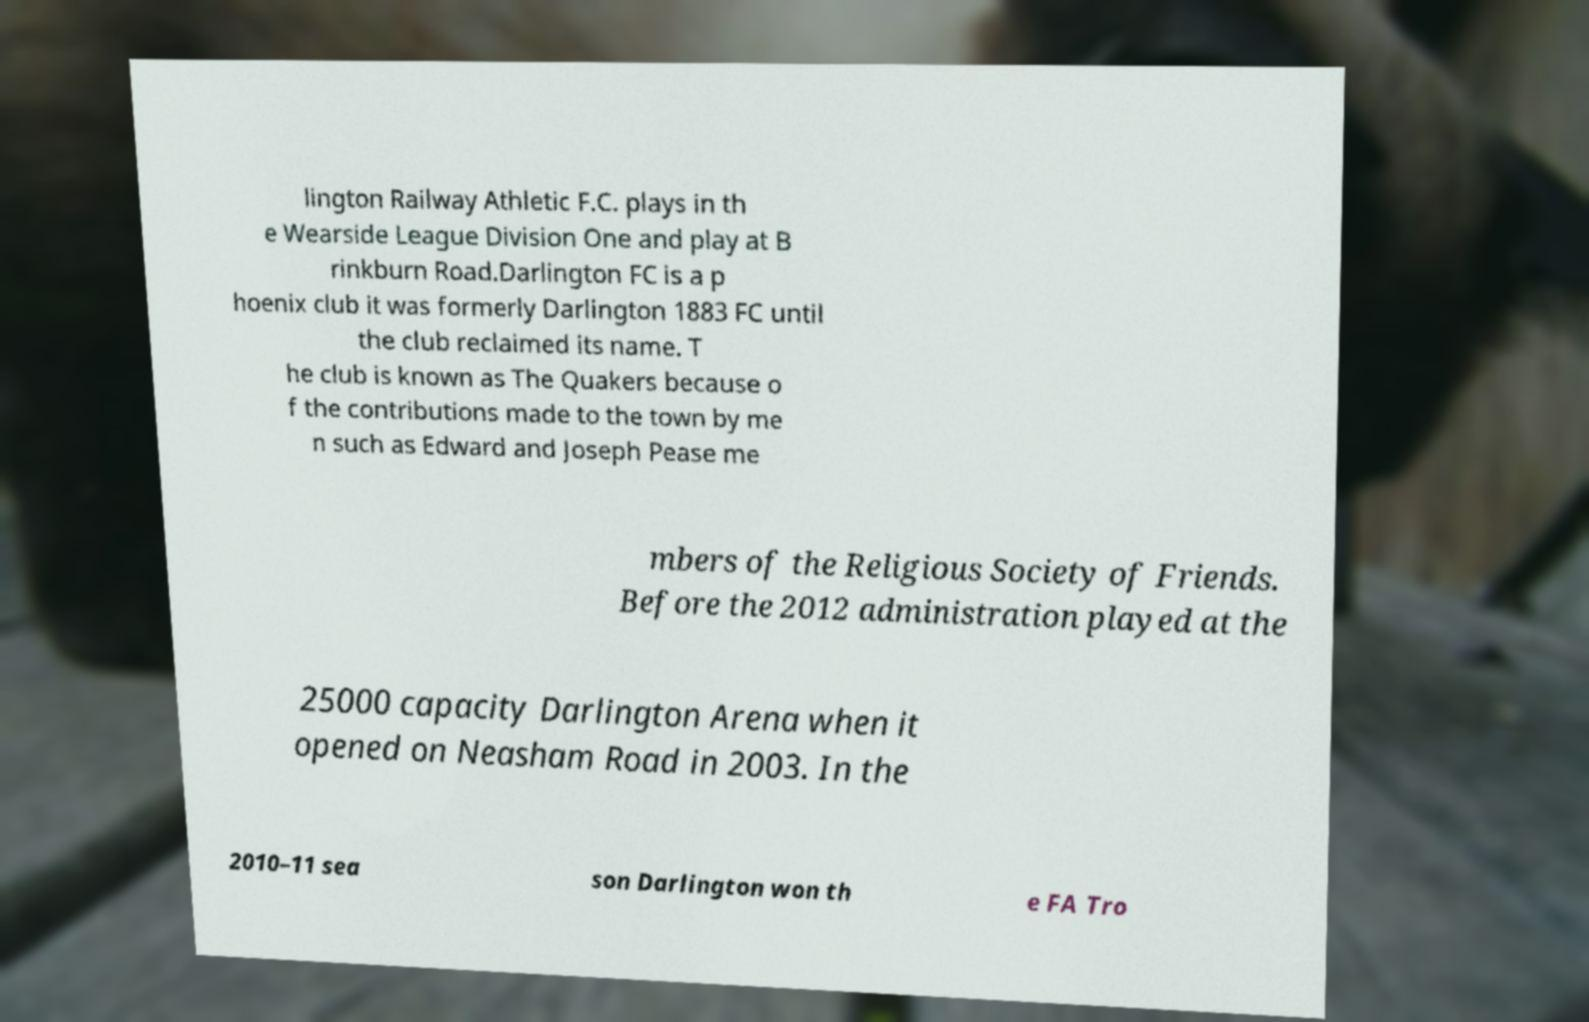Please read and relay the text visible in this image. What does it say? lington Railway Athletic F.C. plays in th e Wearside League Division One and play at B rinkburn Road.Darlington FC is a p hoenix club it was formerly Darlington 1883 FC until the club reclaimed its name. T he club is known as The Quakers because o f the contributions made to the town by me n such as Edward and Joseph Pease me mbers of the Religious Society of Friends. Before the 2012 administration played at the 25000 capacity Darlington Arena when it opened on Neasham Road in 2003. In the 2010–11 sea son Darlington won th e FA Tro 